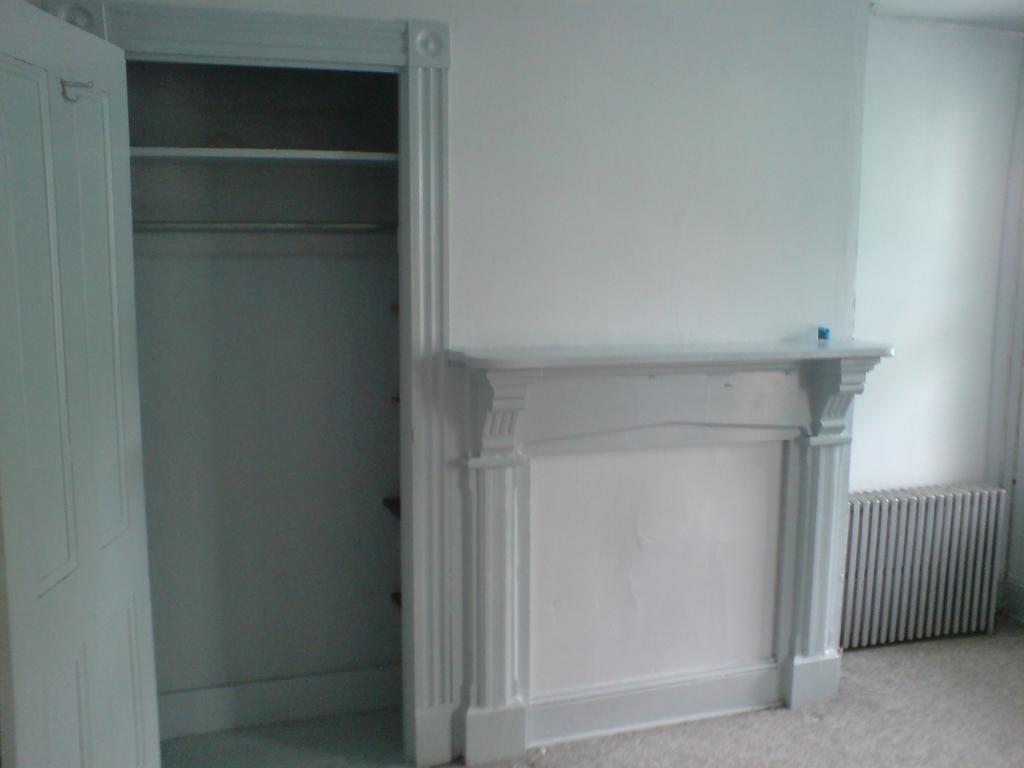What type of structure can be seen in the image? There is a door and a wall visible in the image. What is attached to the wall? There is a stand with pillars on the wall. What is located near the stand? There is an object near the stand. What else can be seen in the background of the image? There is another wall visible in the background. Can you see any bones in the image? There are no bones present in the image. Are there any jellyfish visible in the image? There are no jellyfish present in the image. 